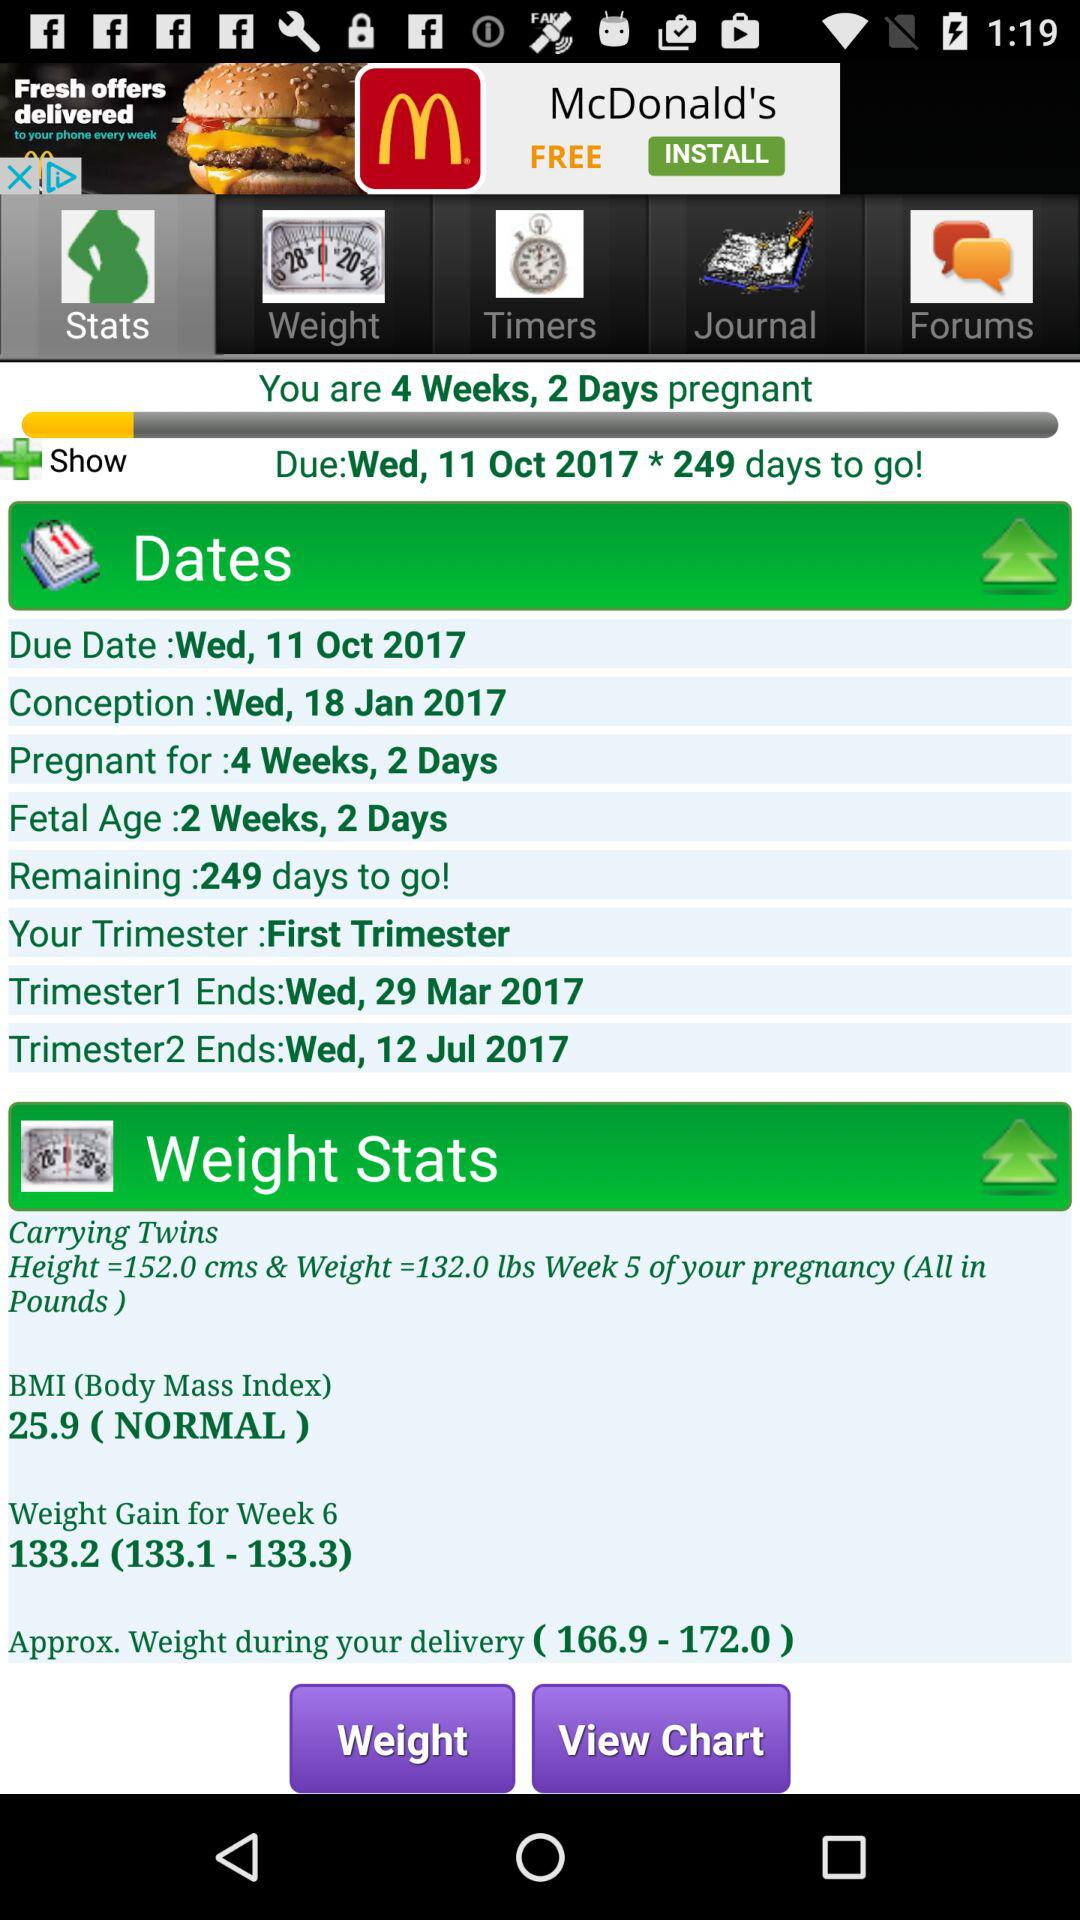How many days have I been pregnant? You are 4 weeks and 2 days pregnant. 